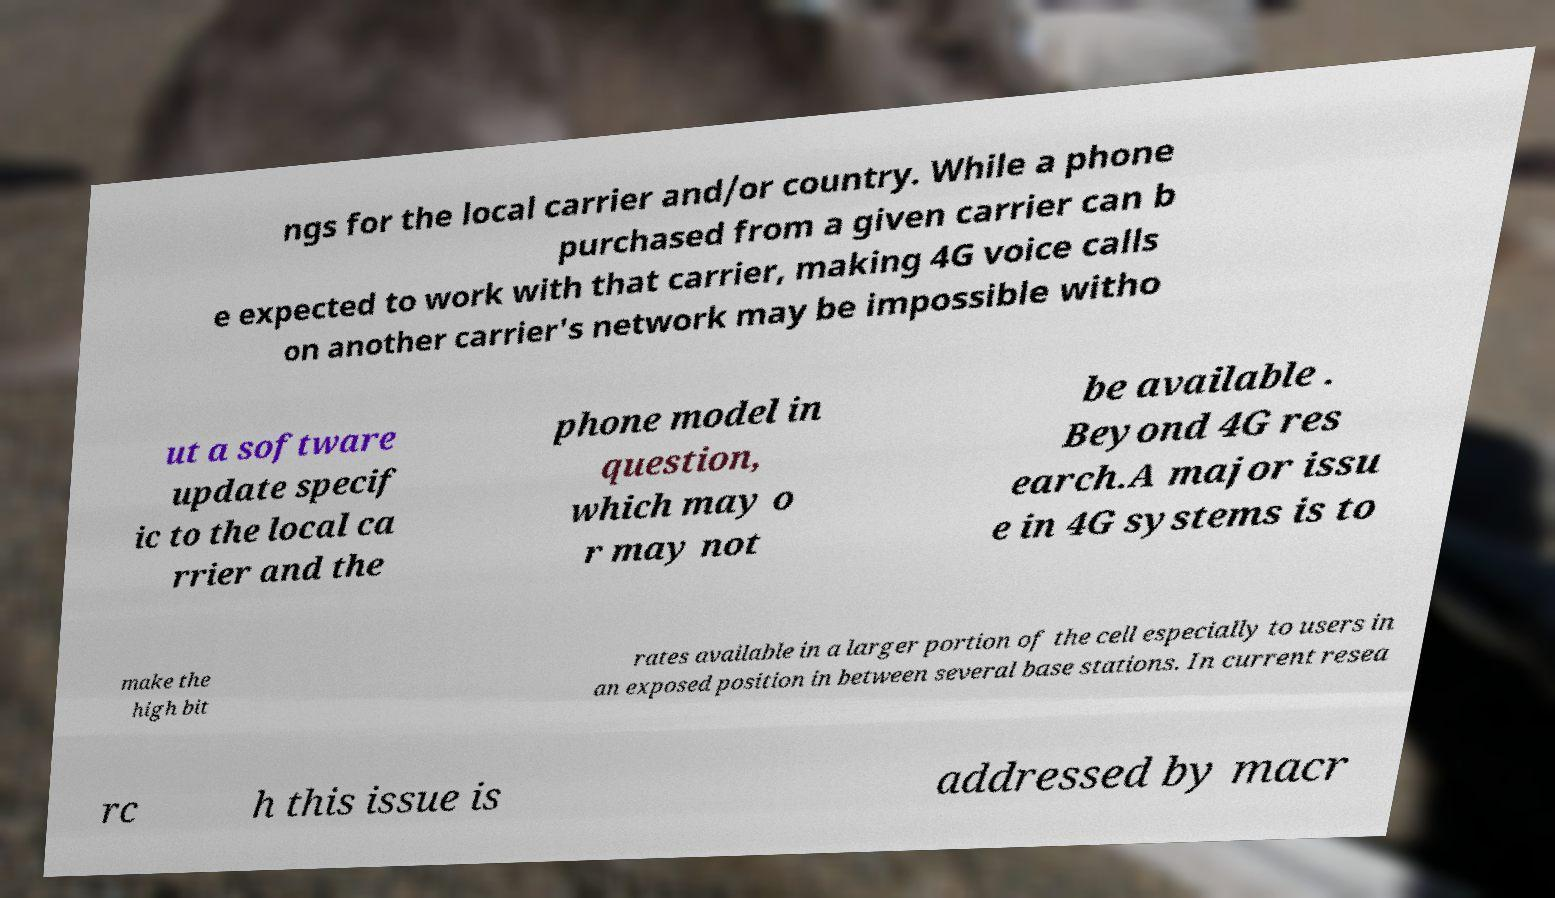I need the written content from this picture converted into text. Can you do that? ngs for the local carrier and/or country. While a phone purchased from a given carrier can b e expected to work with that carrier, making 4G voice calls on another carrier's network may be impossible witho ut a software update specif ic to the local ca rrier and the phone model in question, which may o r may not be available . Beyond 4G res earch.A major issu e in 4G systems is to make the high bit rates available in a larger portion of the cell especially to users in an exposed position in between several base stations. In current resea rc h this issue is addressed by macr 